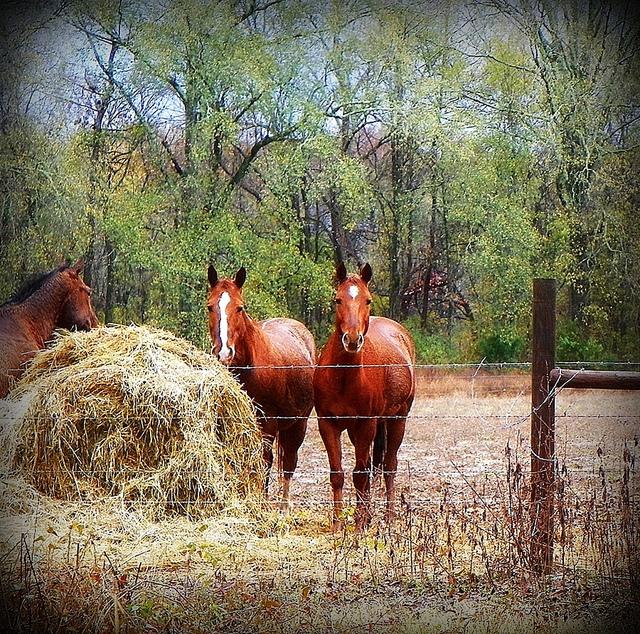Is the horses eating hay?
Quick response, please. Yes. How many horses are there?
Short answer required. 3. How many horses are facing the photographer?
Keep it brief. 2. 